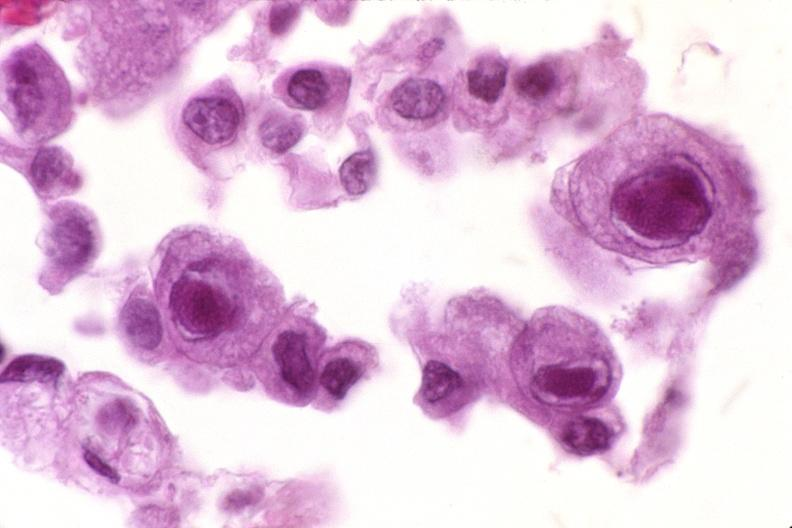what is present?
Answer the question using a single word or phrase. Respiratory 